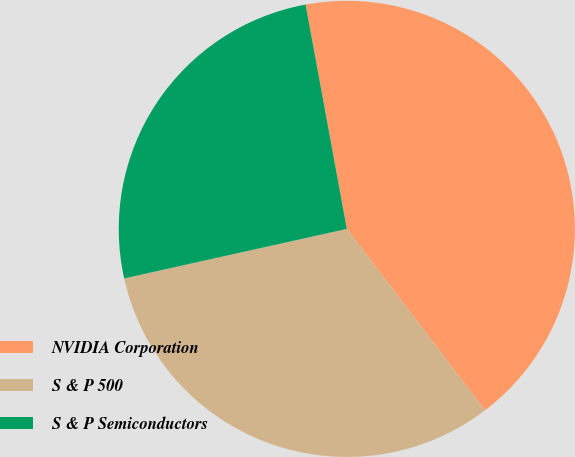Convert chart to OTSL. <chart><loc_0><loc_0><loc_500><loc_500><pie_chart><fcel>NVIDIA Corporation<fcel>S & P 500<fcel>S & P Semiconductors<nl><fcel>42.53%<fcel>31.88%<fcel>25.59%<nl></chart> 